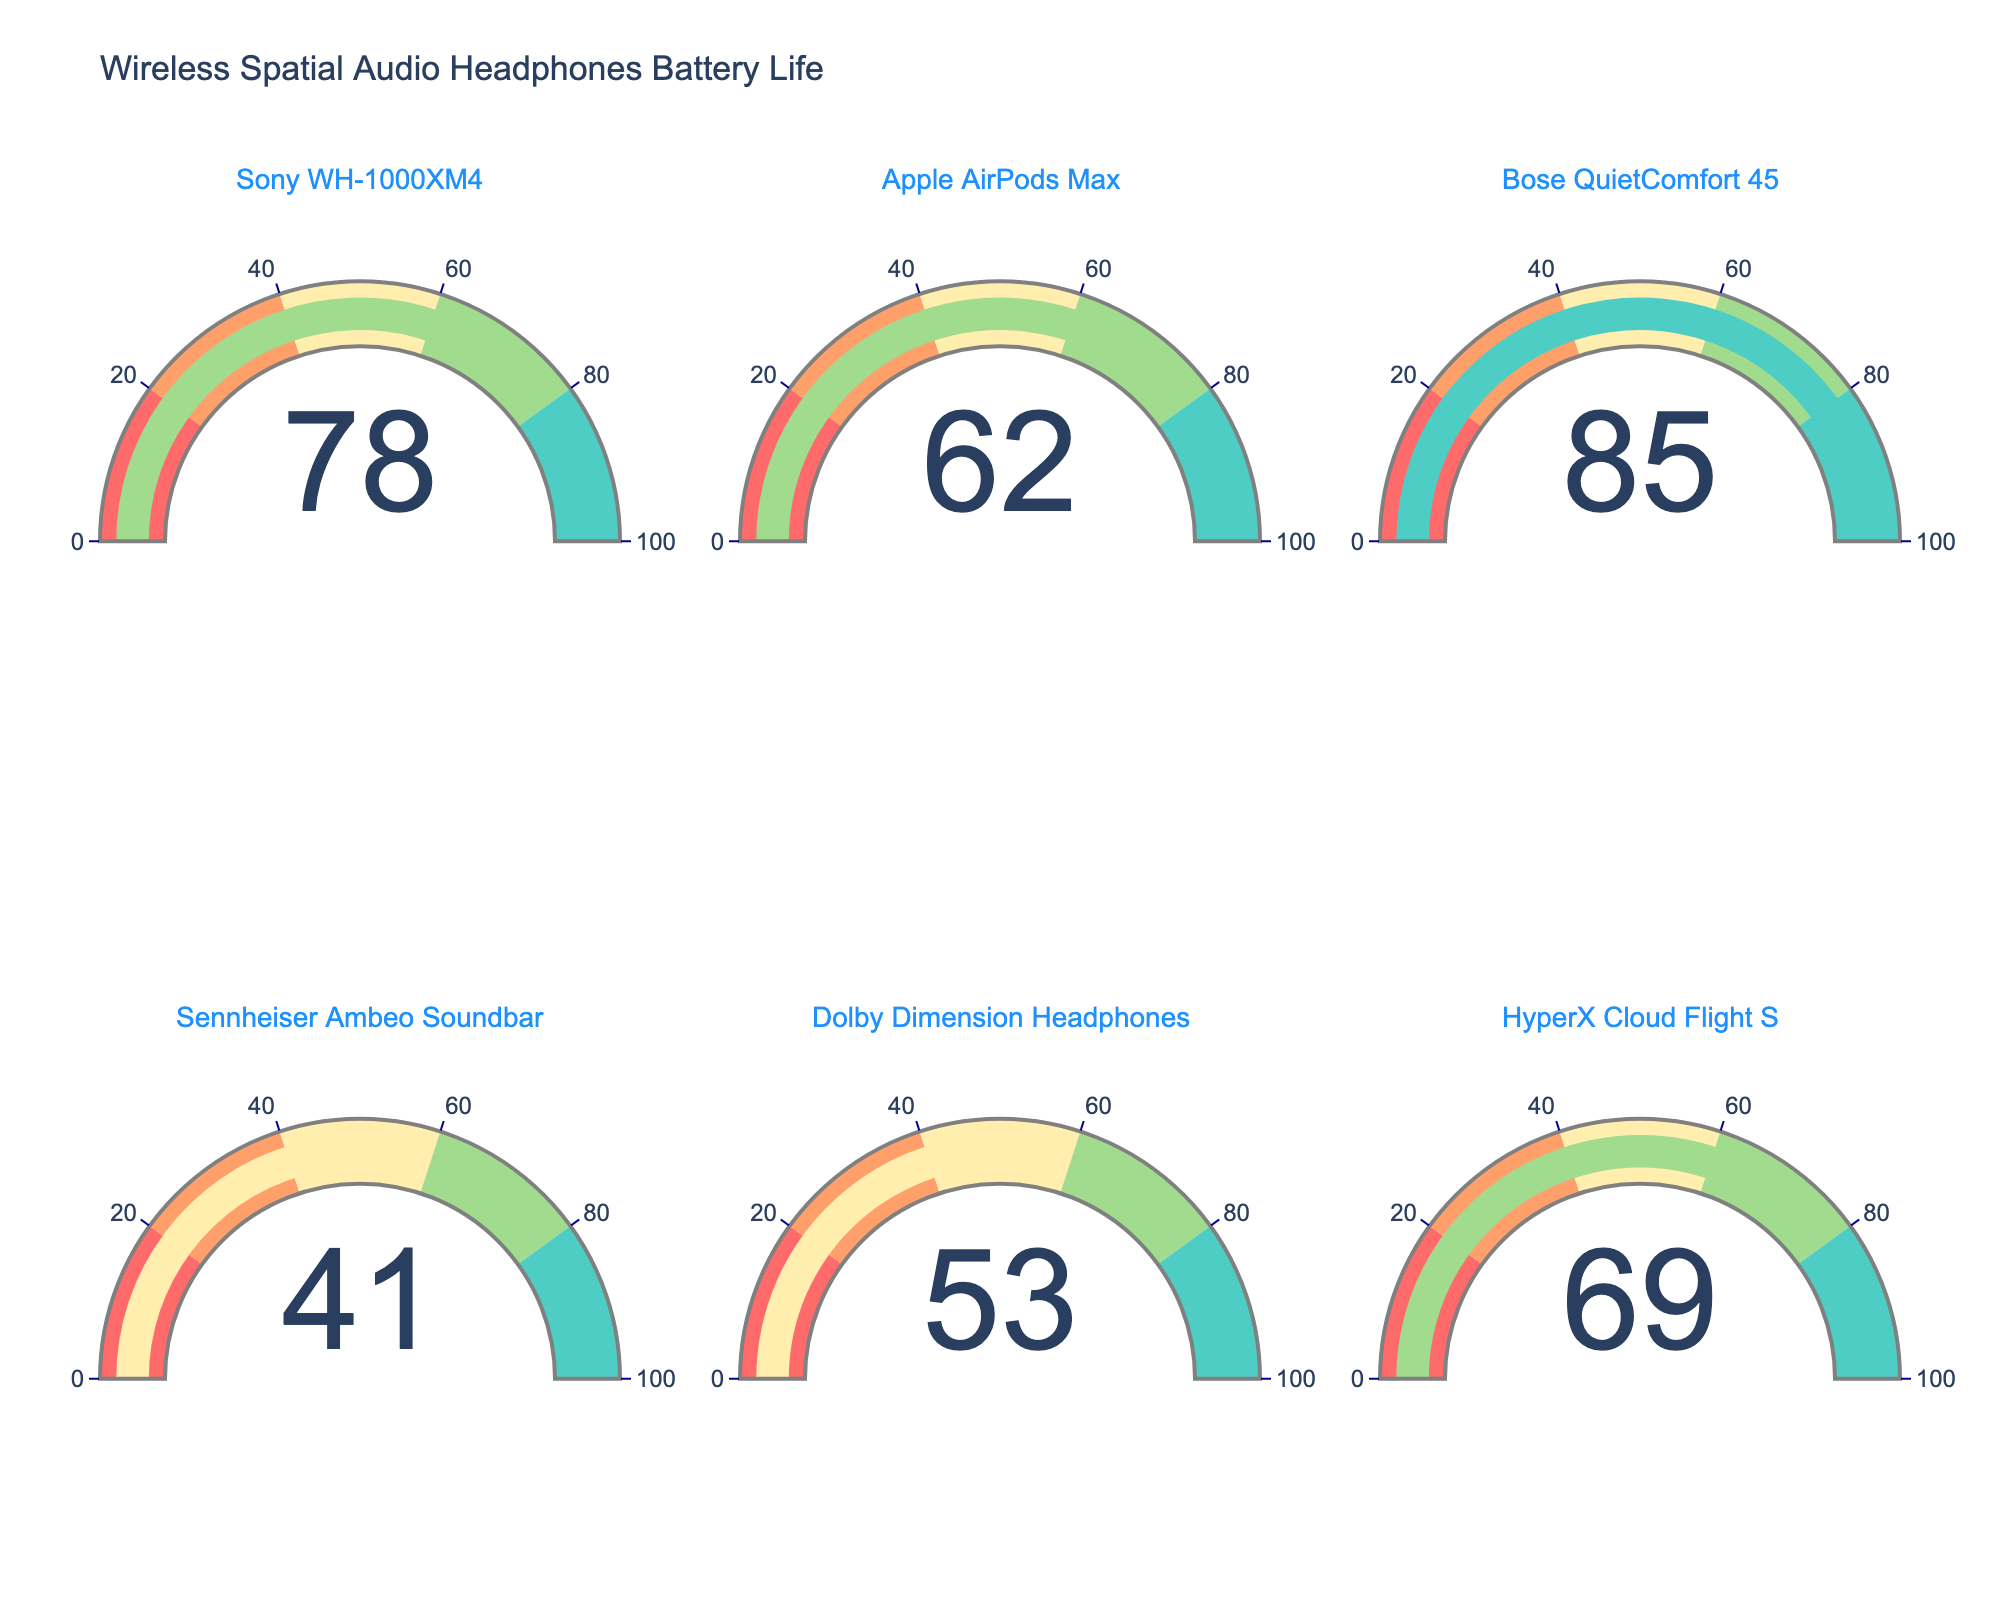What's the title of the figure? The title is usually shown at the top of the figure. Look at the top section to identify the title.
Answer: Wireless Spatial Audio Headphones Battery Life How many devices are displayed in the figure? Count the number of gauges, as each represents one device.
Answer: 6 Which device has the highest battery percentage? Look for the gauge with the highest number.
Answer: Bose QuietComfort 45 Which device has the lowest battery percentage? Look for the gauge with the lowest number.
Answer: Sennheiser Ambeo Soundbar Are the battery percentages for any two devices equal? Compare the values of each gauge.
Answer: No Which device has a battery percentage between 60 and 70? Identify the gauges with values falling between 60 and 70.
Answer: Apple AirPods Max, HyperX Cloud Flight S What's the average battery percentage of all devices? Sum the percentages and divide by the number of devices: (78 + 62 + 85 + 41 + 53 + 69) / 6 = 64.67
Answer: 64.67 What's the total battery remaining in the figure, in percentages? Sum all the percentages: 78 + 62 + 85 + 41 + 53 + 69
Answer: 388 How much more battery does Bose QuietComfort 45 have compared to Sennheiser Ambeo Soundbar? Subtract the battery percentage of Sennheiser from Bose: 85 - 41
Answer: 44 Which devices have a battery percentage above the median value of 62? Identify values greater than 62 from the gauges: Sony WH-1000XM4, Bose QuietComfort 45, HyperX Cloud Flight S
Answer: Sony WH-1000XM4, Bose QuietComfort 45, HyperX Cloud Flight S 